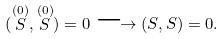<formula> <loc_0><loc_0><loc_500><loc_500>( \stackrel { ( 0 ) } { S } , \stackrel { ( 0 ) } { S } ) = 0 \longrightarrow ( S , S ) = 0 .</formula> 